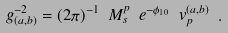<formula> <loc_0><loc_0><loc_500><loc_500>g _ { ( a , b ) } ^ { - 2 } = ( 2 \pi ) ^ { - 1 } \ M _ { s } ^ { p } \ e ^ { - \phi _ { 1 0 } } \ v _ { p } ^ { ( a , b ) } \ .</formula> 